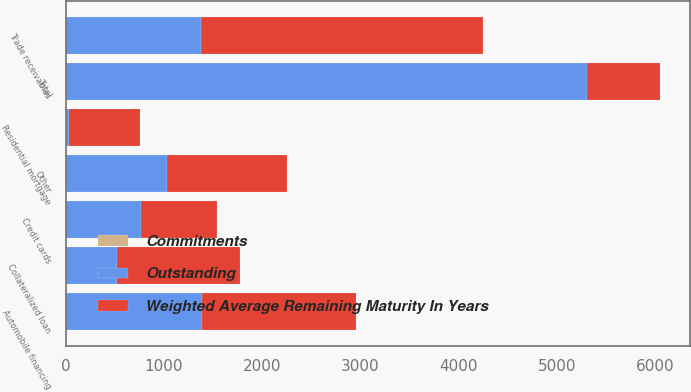Convert chart. <chart><loc_0><loc_0><loc_500><loc_500><stacked_bar_chart><ecel><fcel>Trade receivables<fcel>Automobile financing<fcel>Collateralized loan<fcel>Credit cards<fcel>Residential mortgage<fcel>Other<fcel>Total<nl><fcel>Outstanding<fcel>1375<fcel>1387<fcel>519<fcel>769<fcel>37<fcel>1031<fcel>5304<nl><fcel>Weighted Average Remaining Maturity In Years<fcel>2865<fcel>1565<fcel>1257<fcel>775<fcel>720<fcel>1224<fcel>744.5<nl><fcel>Commitments<fcel>2.63<fcel>4.06<fcel>2.54<fcel>0.26<fcel>0.9<fcel>1.89<fcel>2.41<nl></chart> 